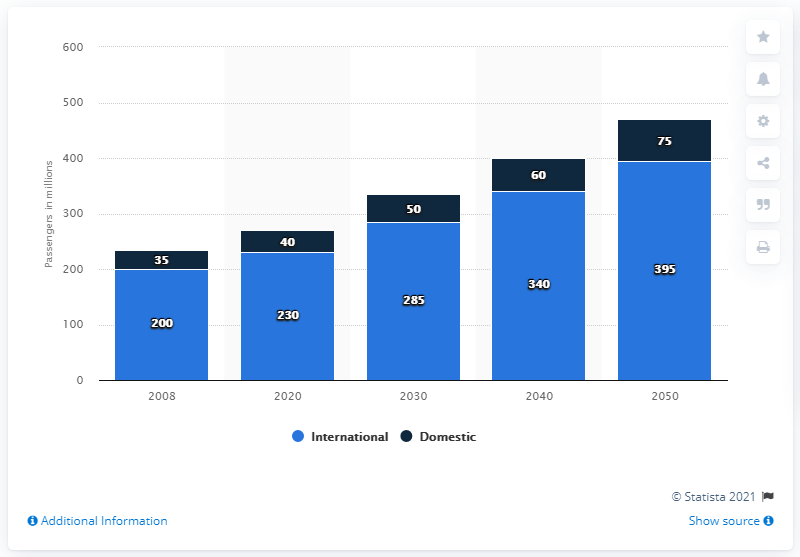Identify some key points in this picture. In 2008, the forecasted number of passengers is expected to be the lowest among all years. The total number of domestic passengers is 260. 